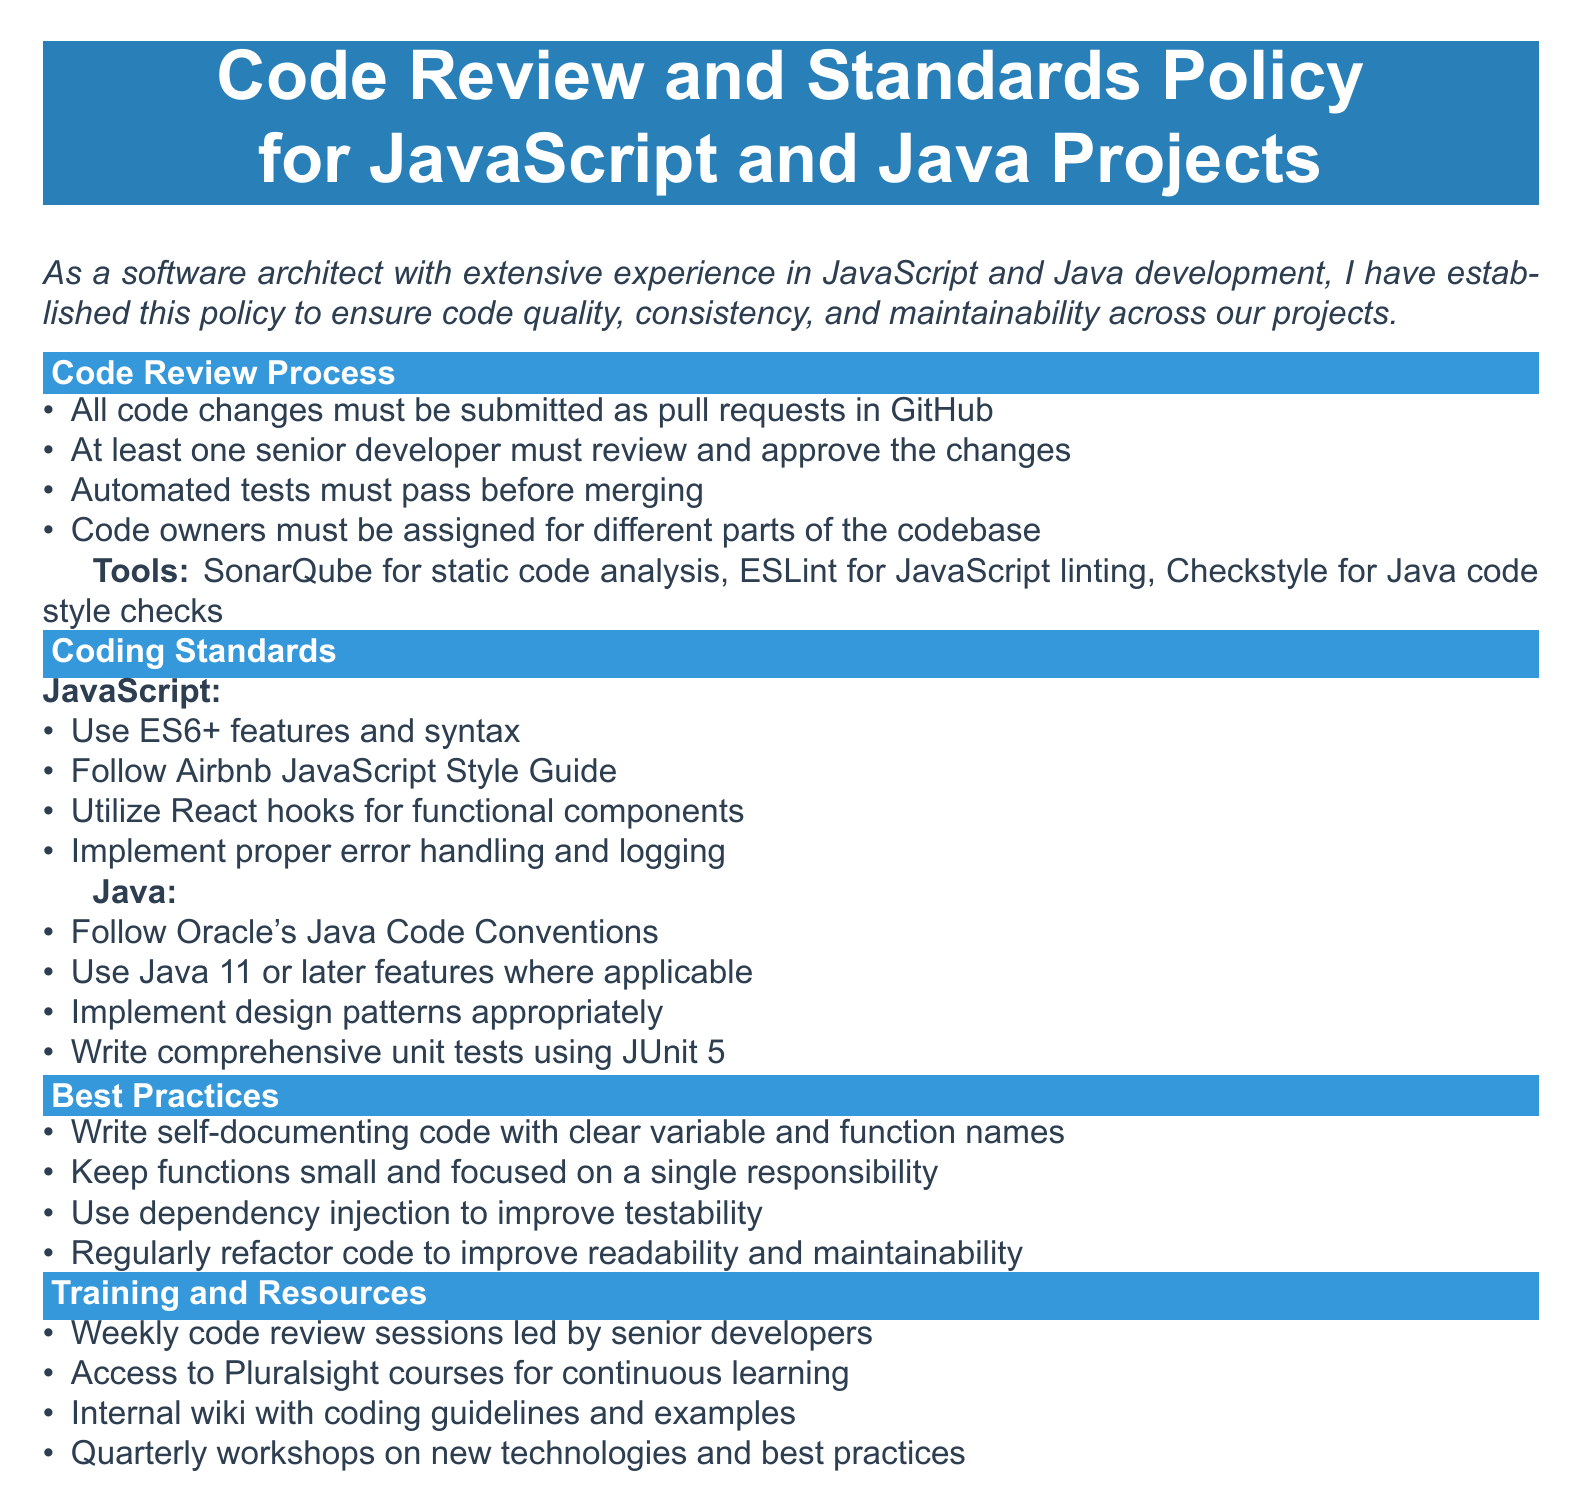What must be submitted as part of the code review process? The document specifies that all code changes must be submitted as pull requests in GitHub.
Answer: pull requests in GitHub Who must review and approve the code changes? According to the document, at least one senior developer must review and approve the changes.
Answer: one senior developer Which static code analysis tool is mentioned in the policy? The document lists SonarQube as the tool for static code analysis.
Answer: SonarQube What coding standard does the JavaScript section follow? The document states to follow the Airbnb JavaScript Style Guide for coding standards.
Answer: Airbnb JavaScript Style Guide What is emphasized as a best practice for code functions? The document advises to keep functions small and focused on a single responsibility.
Answer: small and focused on a single responsibility Which Java version should be used according to the coding standards? The Java section of the policy mentions using Java 11 or later features where applicable.
Answer: Java 11 or later How frequently are code review sessions held? The policy states that weekly code review sessions are led by senior developers.
Answer: weekly What is one of the resources offered for training? The document mentions access to Pluralsight courses for continuous learning.
Answer: Pluralsight courses What type of workshops are held quarterly? The policy specifies that quarterly workshops on new technologies and best practices are conducted.
Answer: new technologies and best practices 